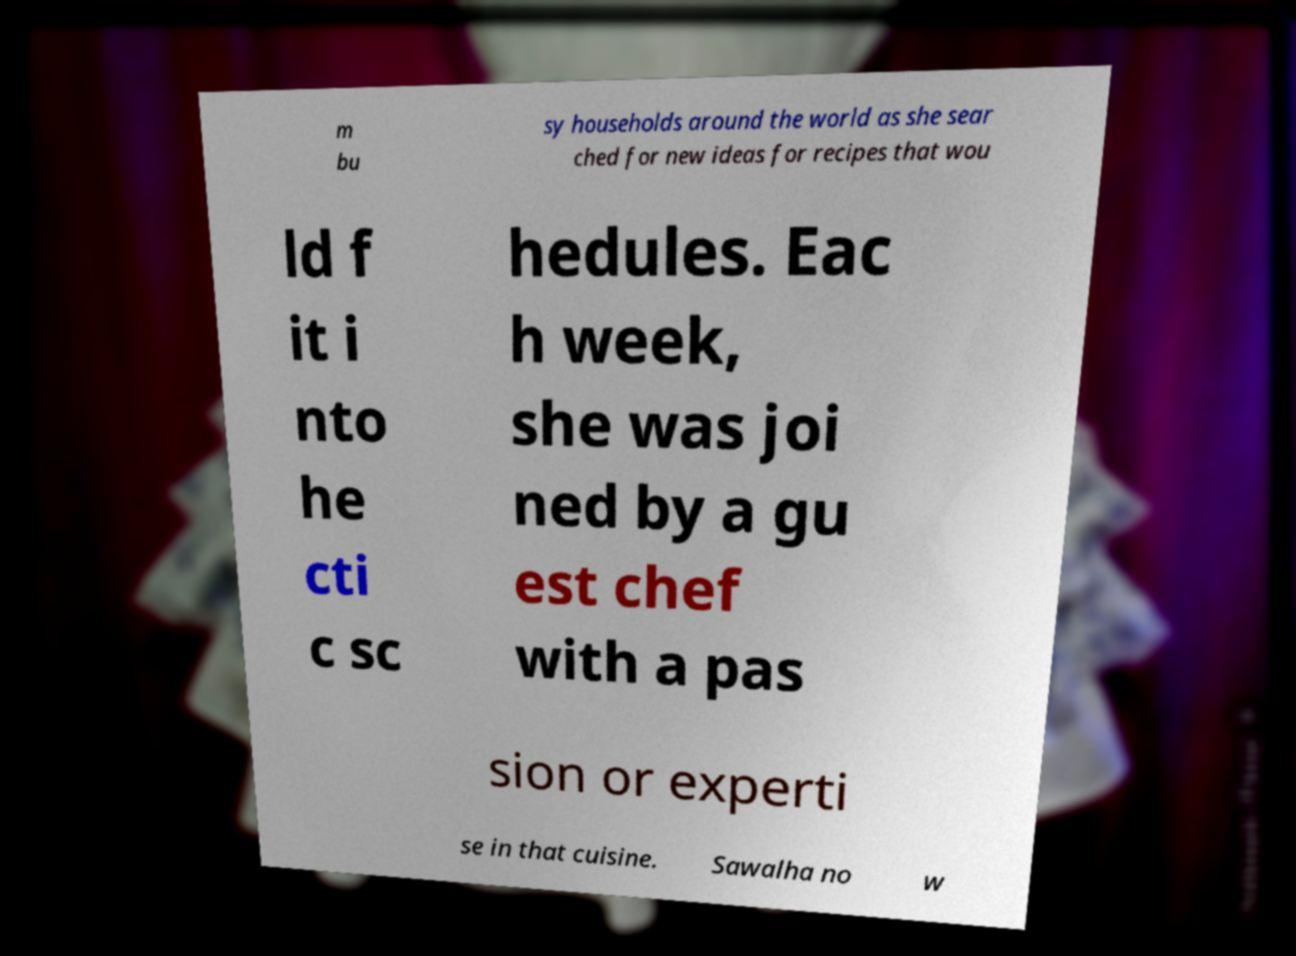What messages or text are displayed in this image? I need them in a readable, typed format. m bu sy households around the world as she sear ched for new ideas for recipes that wou ld f it i nto he cti c sc hedules. Eac h week, she was joi ned by a gu est chef with a pas sion or experti se in that cuisine. Sawalha no w 